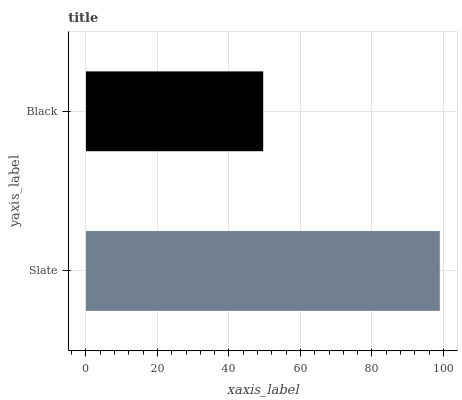Is Black the minimum?
Answer yes or no. Yes. Is Slate the maximum?
Answer yes or no. Yes. Is Black the maximum?
Answer yes or no. No. Is Slate greater than Black?
Answer yes or no. Yes. Is Black less than Slate?
Answer yes or no. Yes. Is Black greater than Slate?
Answer yes or no. No. Is Slate less than Black?
Answer yes or no. No. Is Slate the high median?
Answer yes or no. Yes. Is Black the low median?
Answer yes or no. Yes. Is Black the high median?
Answer yes or no. No. Is Slate the low median?
Answer yes or no. No. 